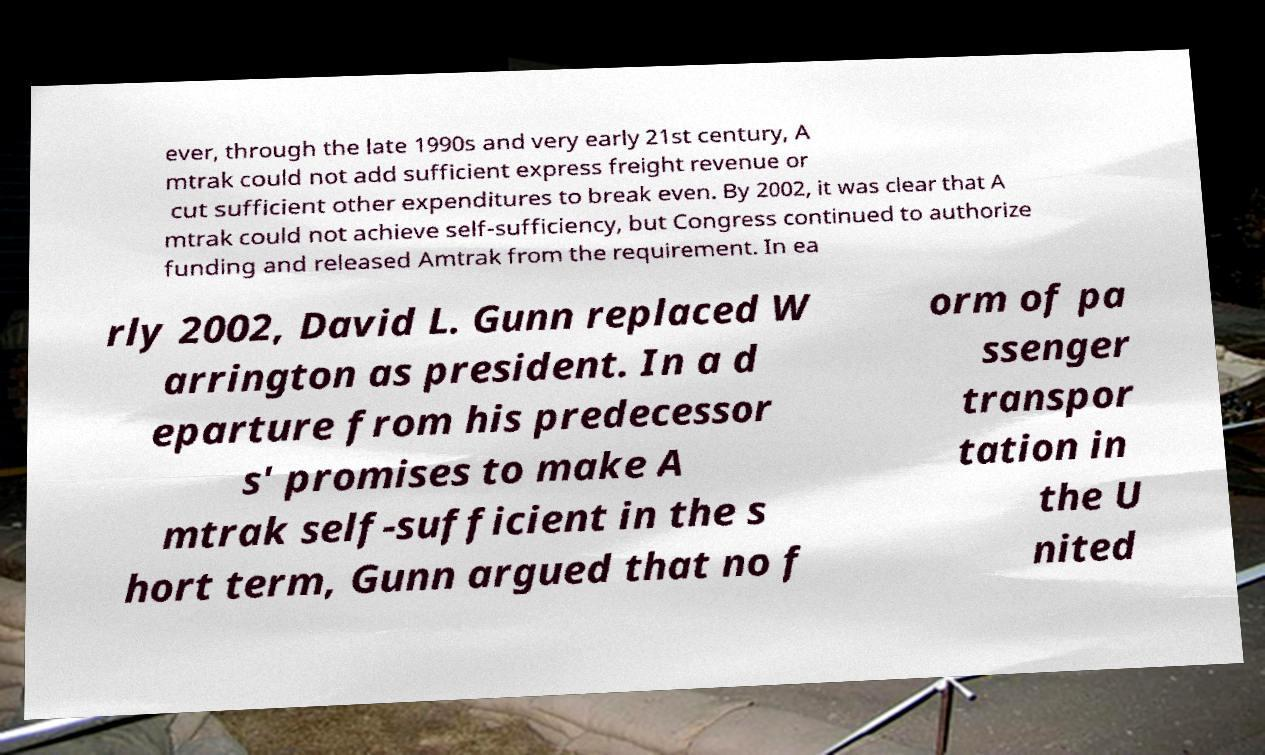Could you extract and type out the text from this image? ever, through the late 1990s and very early 21st century, A mtrak could not add sufficient express freight revenue or cut sufficient other expenditures to break even. By 2002, it was clear that A mtrak could not achieve self-sufficiency, but Congress continued to authorize funding and released Amtrak from the requirement. In ea rly 2002, David L. Gunn replaced W arrington as president. In a d eparture from his predecessor s' promises to make A mtrak self-sufficient in the s hort term, Gunn argued that no f orm of pa ssenger transpor tation in the U nited 